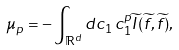<formula> <loc_0><loc_0><loc_500><loc_500>\mu _ { p } = - \int _ { \mathbb { R } ^ { d } } d c _ { 1 } \, c _ { 1 } ^ { p } \widetilde { I } ( \widetilde { f } , \widetilde { f } ) ,</formula> 